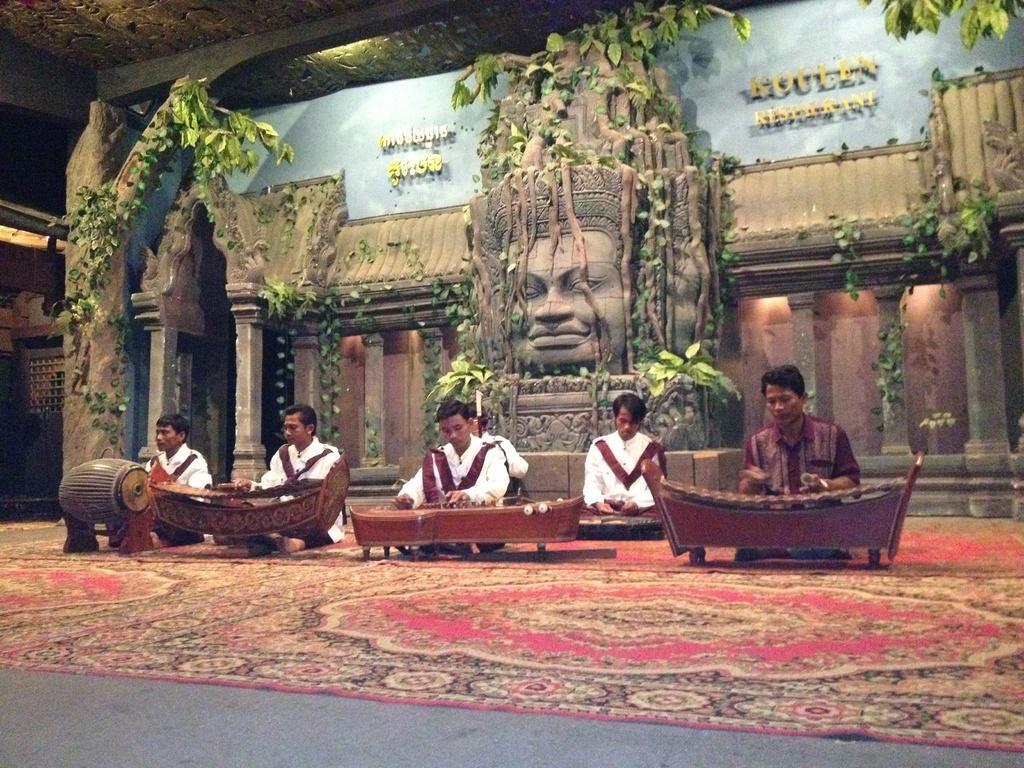How would you summarize this image in a sentence or two? In this image at front there are six people sitting in front of musical instruments. At the bottom there is a mat. At the back side there is a statue and there are plants. Behind the statue there is a wall and we can see lights at the top. 